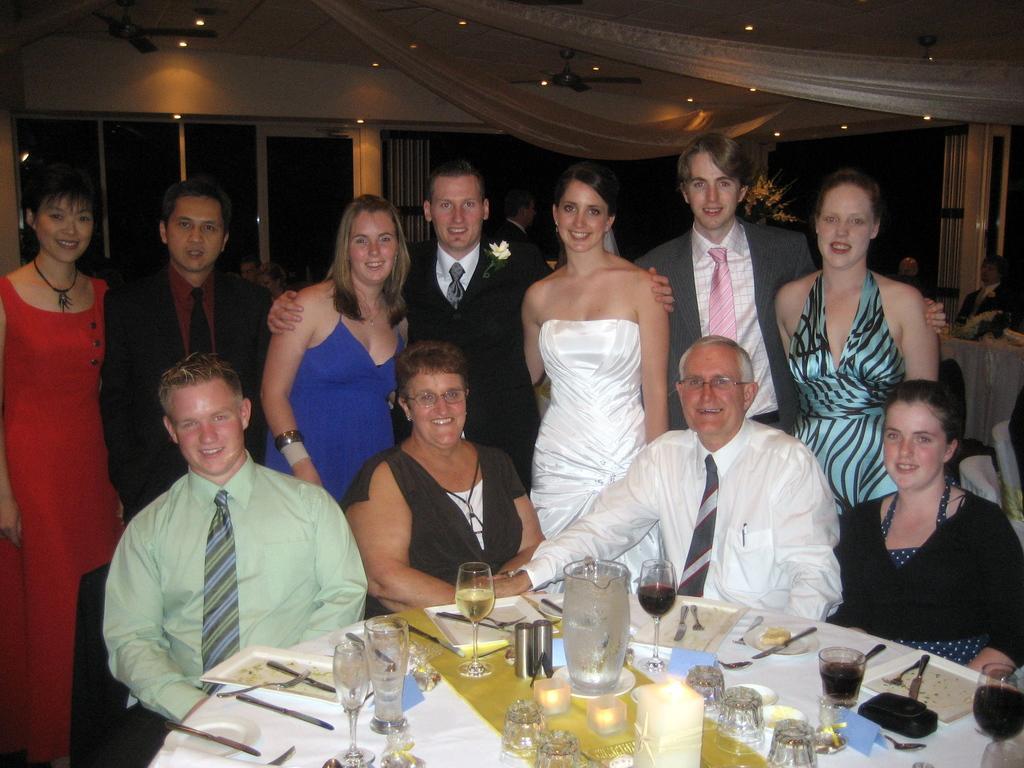Please provide a concise description of this image. In this image we can see some people sitting beside a table containing some glasses, a jar, some knives, forks, spoons, candles, tissue papers and some objects placed on it. We can also see a group of people standing. On the backside we can see a person sitting beside a table, some curtains and the doors. We can also see the ceiling lights and ceiling fans to a roof. 